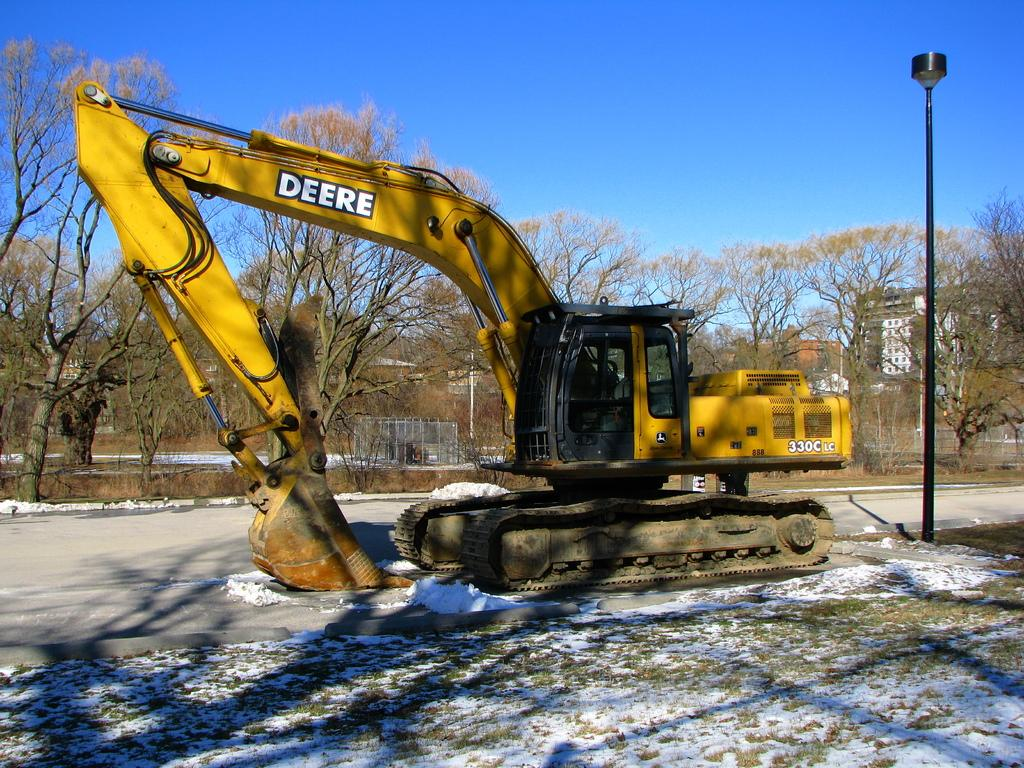What type of vehicle is on the road in the image? There is a crane on the road in the image. What type of natural elements can be seen in the image? There are trees in the image. What type of structures can be seen in the image? There are poles and a fence in the image. What type of illumination is present in the image? There are lights in the image. What type of weather condition is depicted in the image? There is snow in the image. What is visible in the background of the image? The sky is visible in the background of the image. What type of clock is hanging on the fence in the image? There is no clock present in the image; it only features a crane, trees, poles, lights, snow, and the sky. What type of record is being played in the background of the image? There is no record being played in the image; it is a still photograph. 